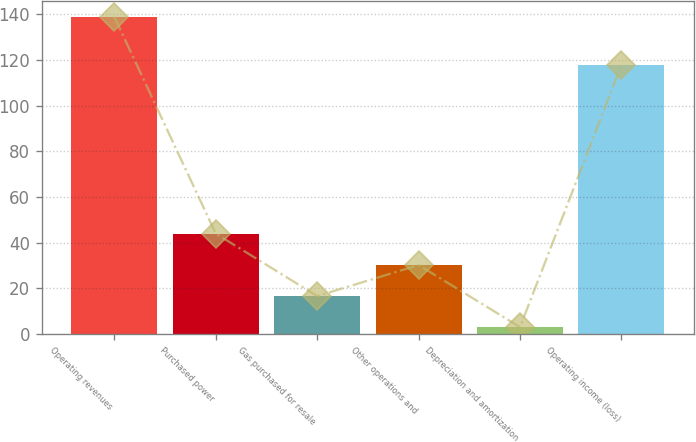<chart> <loc_0><loc_0><loc_500><loc_500><bar_chart><fcel>Operating revenues<fcel>Purchased power<fcel>Gas purchased for resale<fcel>Other operations and<fcel>Depreciation and amortization<fcel>Operating income (loss)<nl><fcel>139<fcel>44<fcel>16.6<fcel>30.2<fcel>3<fcel>118<nl></chart> 